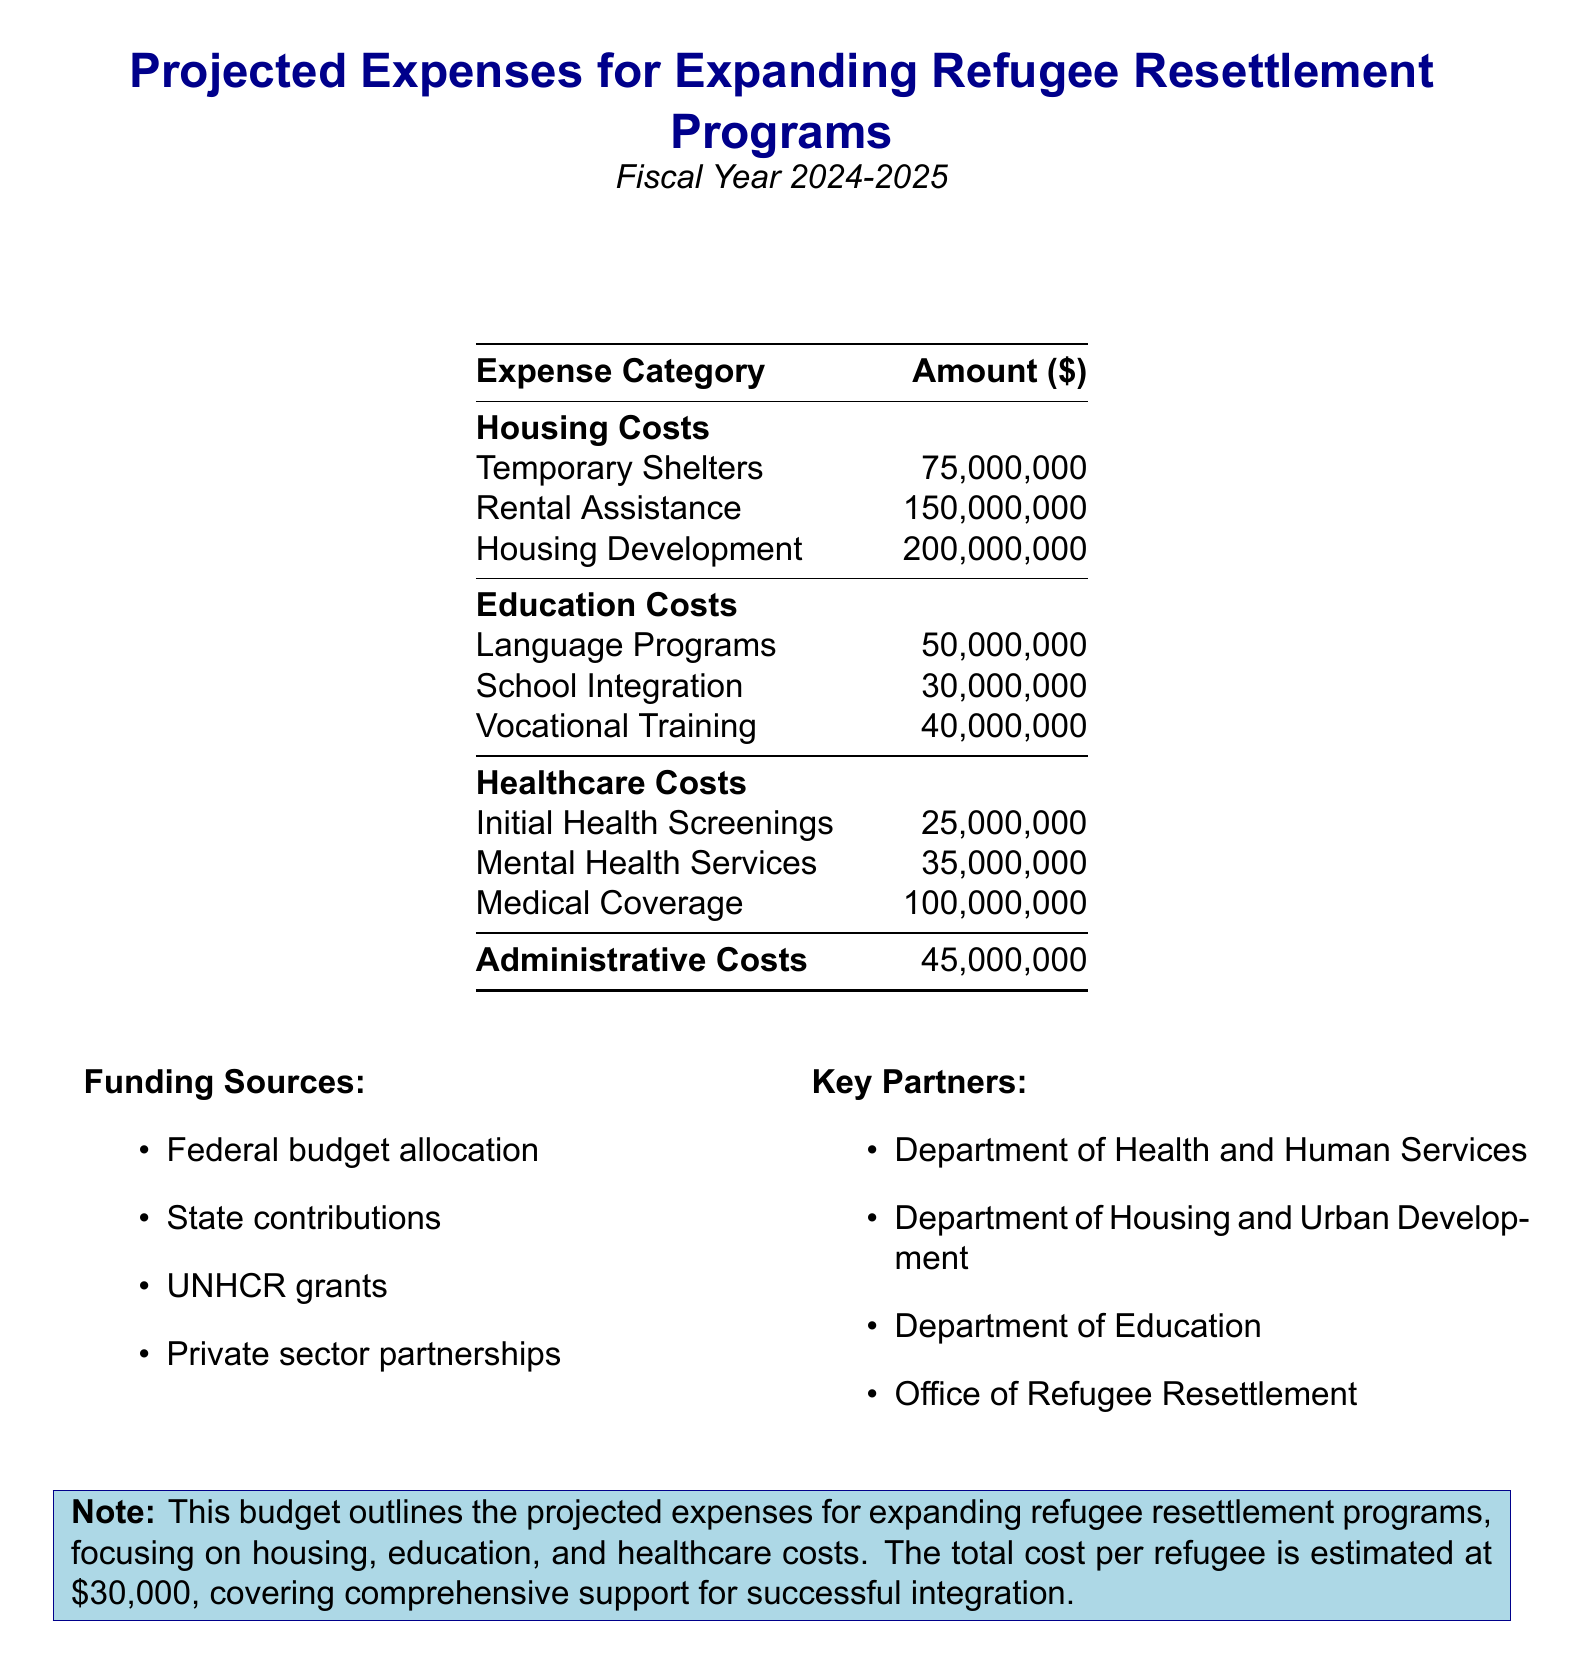What is the total projected cost? The total projected cost is specified in the document as the combined amount for all expenses, which is $750,000,000.
Answer: $750,000,000 How many refugees are projected for resettlement? The document states the number of total refugees projected for resettlement is a key piece of information presented at the beginning.
Answer: 25,000 What is the amount allocated for medical coverage? Medical coverage is explicitly listed in the healthcare costs section of the document with a designated amount.
Answer: $100,000,000 What is the total education cost? To find the total education cost, one needs to sum the individual education expenses provided in the table part of the document.
Answer: $120,000,000 Which department is a key partner for this project? The document lists several key partners, one of which is the Department of Health and Human Services as an important collaborator.
Answer: Department of Health and Human Services What is the cost per refugee? The document specifies the calculation of costs for each refugee, which is a critical detail to understand the overall budgeting.
Answer: $30,000 What is the total housing cost? By aggregating all the housing costs listed, one can determine the total cost specifically allocated for housing.
Answer: $425,000,000 How much is allocated for mental health services? The amount specifically for mental health services is stated under healthcare costs and is a distinct line item.
Answer: $35,000,000 What are the funding sources listed in the document? The funding sources section outlines various origins of financial support for the project, such as federal budget allocation.
Answer: Federal budget allocation, State contributions, UNHCR grants, Private sector partnerships What administrative cost is included in the budget? The document clearly states the administrative costs as a separate line item, which is crucial for overall budgeting.
Answer: $45,000,000 